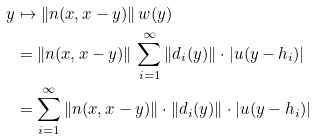<formula> <loc_0><loc_0><loc_500><loc_500>y & \mapsto \| n ( x , x - y ) \| \, w ( y ) \\ & = \| n ( x , x - y ) \| \, \sum _ { i = 1 } ^ { \infty } \| d _ { i } ( y ) \| \cdot | u ( y - h _ { i } ) | \\ & = \sum _ { i = 1 } ^ { \infty } \| n ( x , x - y ) \| \cdot \| d _ { i } ( y ) \| \cdot | u ( y - h _ { i } ) |</formula> 